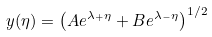Convert formula to latex. <formula><loc_0><loc_0><loc_500><loc_500>y ( \eta ) = \left ( A e ^ { \lambda _ { + } \eta } + B e ^ { \lambda _ { - } \eta } \right ) ^ { 1 / 2 }</formula> 